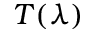Convert formula to latex. <formula><loc_0><loc_0><loc_500><loc_500>T ( \lambda )</formula> 